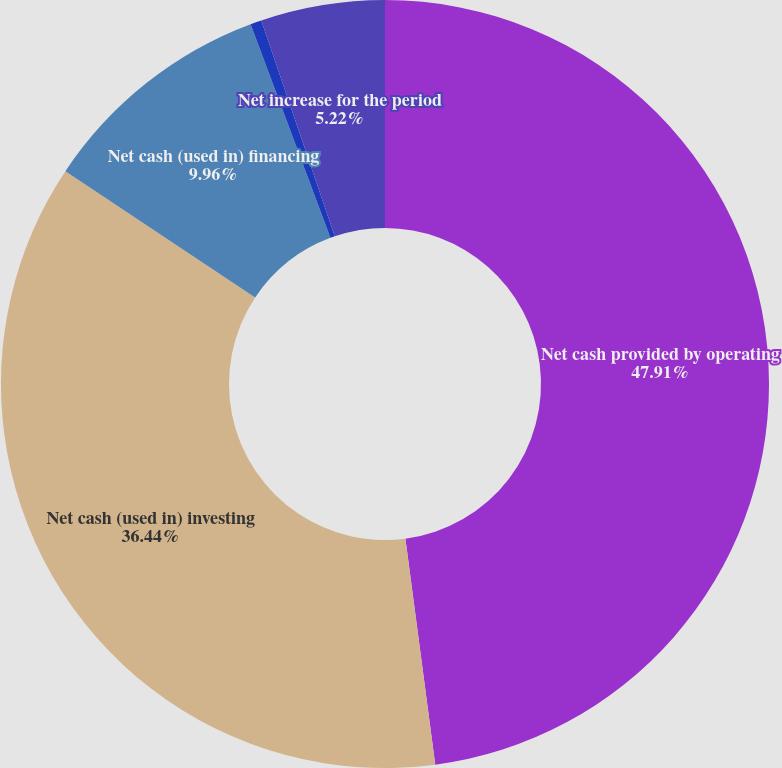Convert chart to OTSL. <chart><loc_0><loc_0><loc_500><loc_500><pie_chart><fcel>Net cash provided by operating<fcel>Net cash (used in) investing<fcel>Net cash (used in) financing<fcel>Effect of exchange rate<fcel>Net increase for the period<nl><fcel>47.91%<fcel>36.44%<fcel>9.96%<fcel>0.47%<fcel>5.22%<nl></chart> 